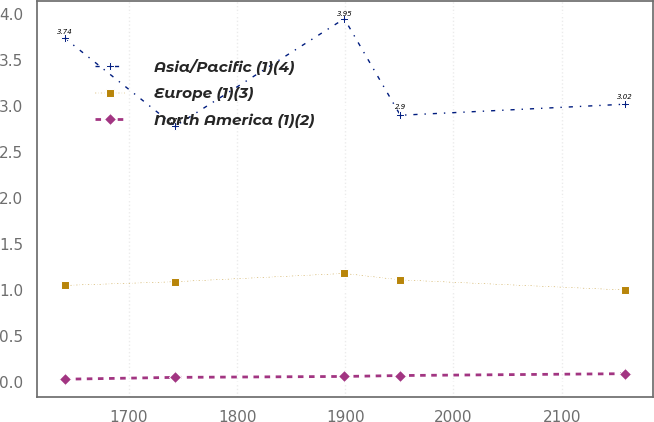Convert chart. <chart><loc_0><loc_0><loc_500><loc_500><line_chart><ecel><fcel>Asia/Pacific (1)(4)<fcel>Europe (1)(3)<fcel>North America (1)(2)<nl><fcel>1640.47<fcel>3.74<fcel>1.05<fcel>0.03<nl><fcel>1742.6<fcel>2.78<fcel>1.09<fcel>0.05<nl><fcel>1899.09<fcel>3.95<fcel>1.18<fcel>0.06<nl><fcel>1950.87<fcel>2.9<fcel>1.11<fcel>0.07<nl><fcel>2158.3<fcel>3.02<fcel>1<fcel>0.09<nl></chart> 